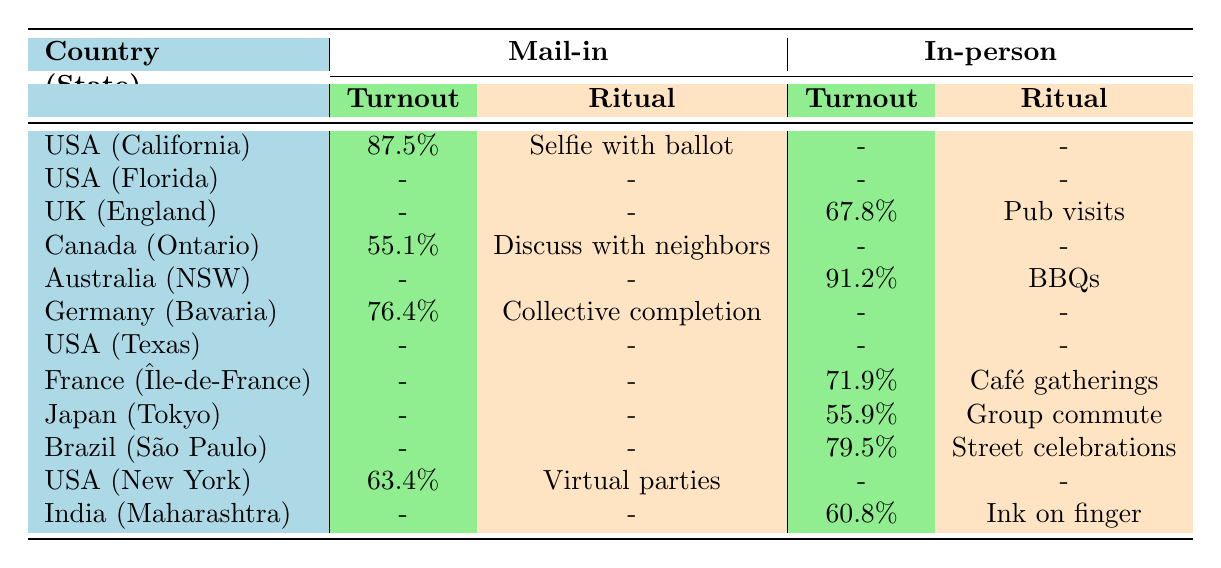What is the highest voter turnout for mail-in voting? The table shows that California has the highest voter turnout for mail-in voting at 87.5%.
Answer: 87.5% Which country had a voter turnout of 91.2% for in-person voting? The table indicates that Australia (New South Wales) had a voter turnout of 91.2% for in-person voting.
Answer: 91.2% Is the ritual observation for early voting in Florida mentioned in the table? The table does not provide any data for mail-in or in-person voting in Florida, so the ritual observation for early voting in Florida is not mentioned.
Answer: No Calculate the average voter turnout for in-person voting across all listed countries. The in-person voter turnouts are 67.8%, 91.2%, 71.9%, 55.9%, 79.5%, and 60.8%. The sum is 67.8 + 91.2 + 71.9 + 55.9 + 79.5 + 60.8 = 427.1, and there are 6 data points, so the average is 427.1 / 6 = 71.18.
Answer: 71.18 Do all the countries listed have ritual observations for mail-in voting? The table shows data for mail-in voting in California, Ontario, and Bavaria; however, not all have ritual observations listed, indicating that not all countries have them.
Answer: No What is the difference in voter turnout between in-person voting in Australia and mail-in voting in Canada? The voter turnout for in-person voting in Australia is 91.2%, while the mail-in voting turnout in Canada is 55.1%. The difference is 91.2 - 55.1 = 36.1%.
Answer: 36.1% Which age group has a voting ritual of "Election day barbecues"? According to the table, the age group of 18-29 in Australia (New South Wales) has the voting ritual of "Election day barbecues."
Answer: 18-29 Are there more participants in mail-in voting or in-person voting across the countries listed? The table indicates that only three countries reported mail-in voting and four reported in-person voting. Given more countries reported in-person voting, it's likely there are more participants.
Answer: Yes 